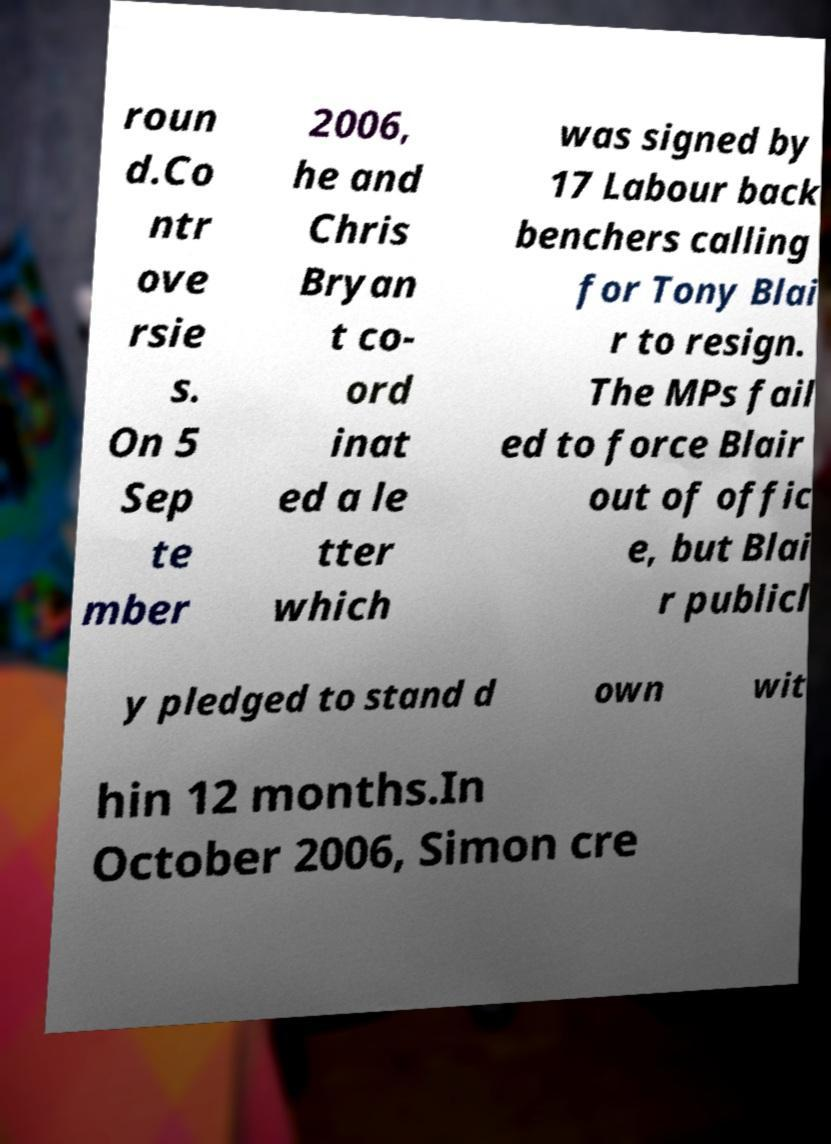What messages or text are displayed in this image? I need them in a readable, typed format. roun d.Co ntr ove rsie s. On 5 Sep te mber 2006, he and Chris Bryan t co- ord inat ed a le tter which was signed by 17 Labour back benchers calling for Tony Blai r to resign. The MPs fail ed to force Blair out of offic e, but Blai r publicl y pledged to stand d own wit hin 12 months.In October 2006, Simon cre 